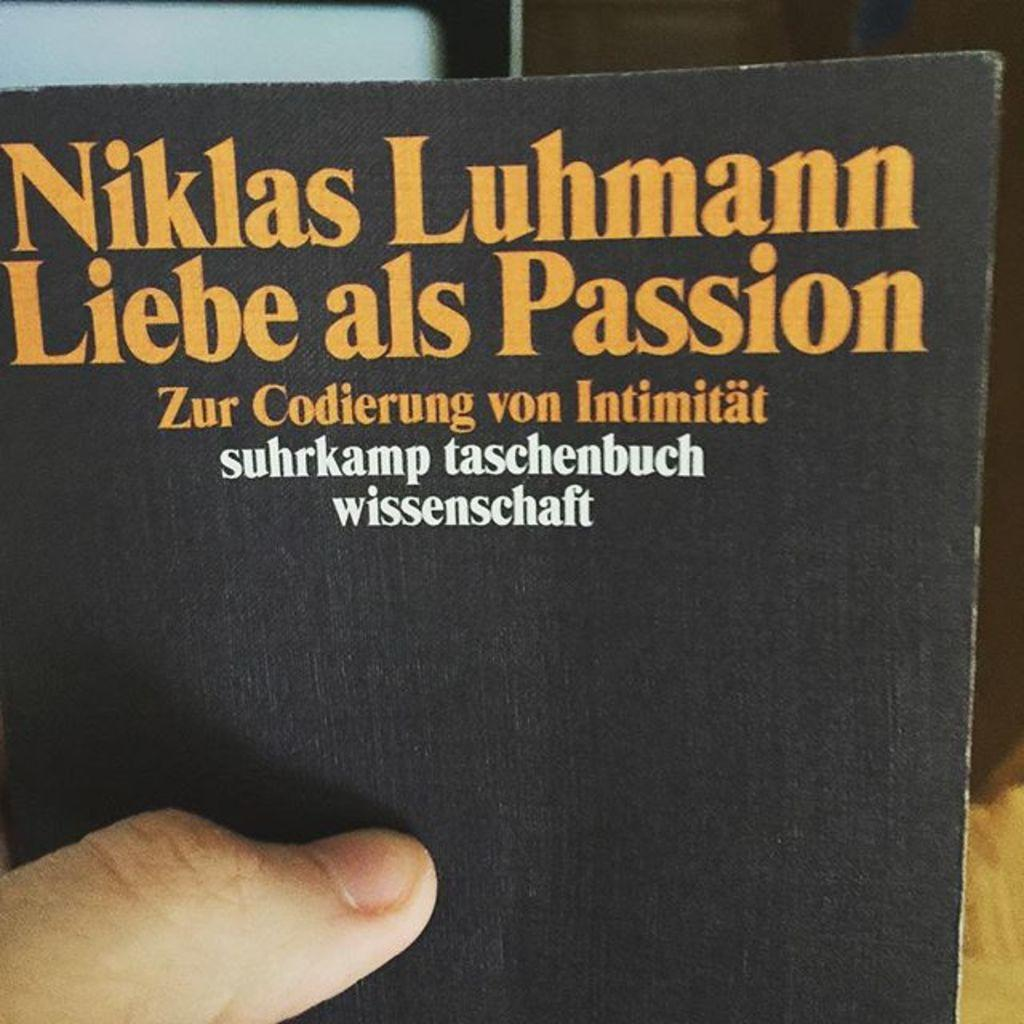<image>
Offer a succinct explanation of the picture presented. a black book with white text saying Sukrkamp Taschenbuch Wissenschaft 